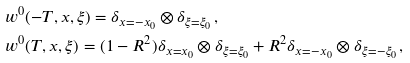<formula> <loc_0><loc_0><loc_500><loc_500>& w ^ { 0 } ( - T , x , \xi ) = \delta _ { x = - x _ { 0 } } \otimes \delta _ { \xi = \xi _ { 0 } } \, , \\ & w ^ { 0 } ( T , x , \xi ) = ( 1 - R ^ { 2 } ) \delta _ { x = x _ { 0 } } \otimes \delta _ { \xi = \xi _ { 0 } } + R ^ { 2 } \delta _ { x = - x _ { 0 } } \otimes \delta _ { \xi = - \xi _ { 0 } } \, ,</formula> 